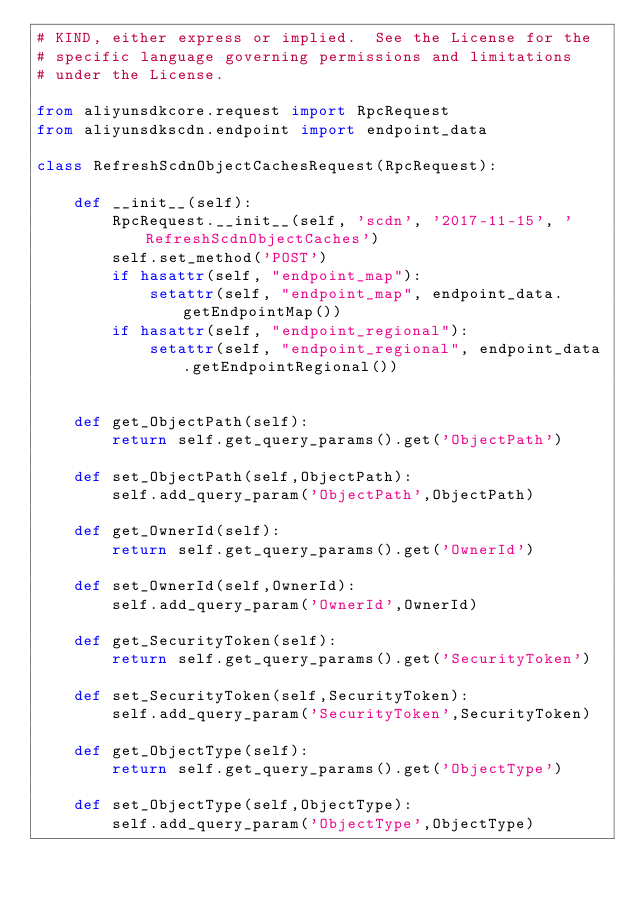<code> <loc_0><loc_0><loc_500><loc_500><_Python_># KIND, either express or implied.  See the License for the
# specific language governing permissions and limitations
# under the License.

from aliyunsdkcore.request import RpcRequest
from aliyunsdkscdn.endpoint import endpoint_data

class RefreshScdnObjectCachesRequest(RpcRequest):

	def __init__(self):
		RpcRequest.__init__(self, 'scdn', '2017-11-15', 'RefreshScdnObjectCaches')
		self.set_method('POST')
		if hasattr(self, "endpoint_map"):
			setattr(self, "endpoint_map", endpoint_data.getEndpointMap())
		if hasattr(self, "endpoint_regional"):
			setattr(self, "endpoint_regional", endpoint_data.getEndpointRegional())


	def get_ObjectPath(self):
		return self.get_query_params().get('ObjectPath')

	def set_ObjectPath(self,ObjectPath):
		self.add_query_param('ObjectPath',ObjectPath)

	def get_OwnerId(self):
		return self.get_query_params().get('OwnerId')

	def set_OwnerId(self,OwnerId):
		self.add_query_param('OwnerId',OwnerId)

	def get_SecurityToken(self):
		return self.get_query_params().get('SecurityToken')

	def set_SecurityToken(self,SecurityToken):
		self.add_query_param('SecurityToken',SecurityToken)

	def get_ObjectType(self):
		return self.get_query_params().get('ObjectType')

	def set_ObjectType(self,ObjectType):
		self.add_query_param('ObjectType',ObjectType)</code> 